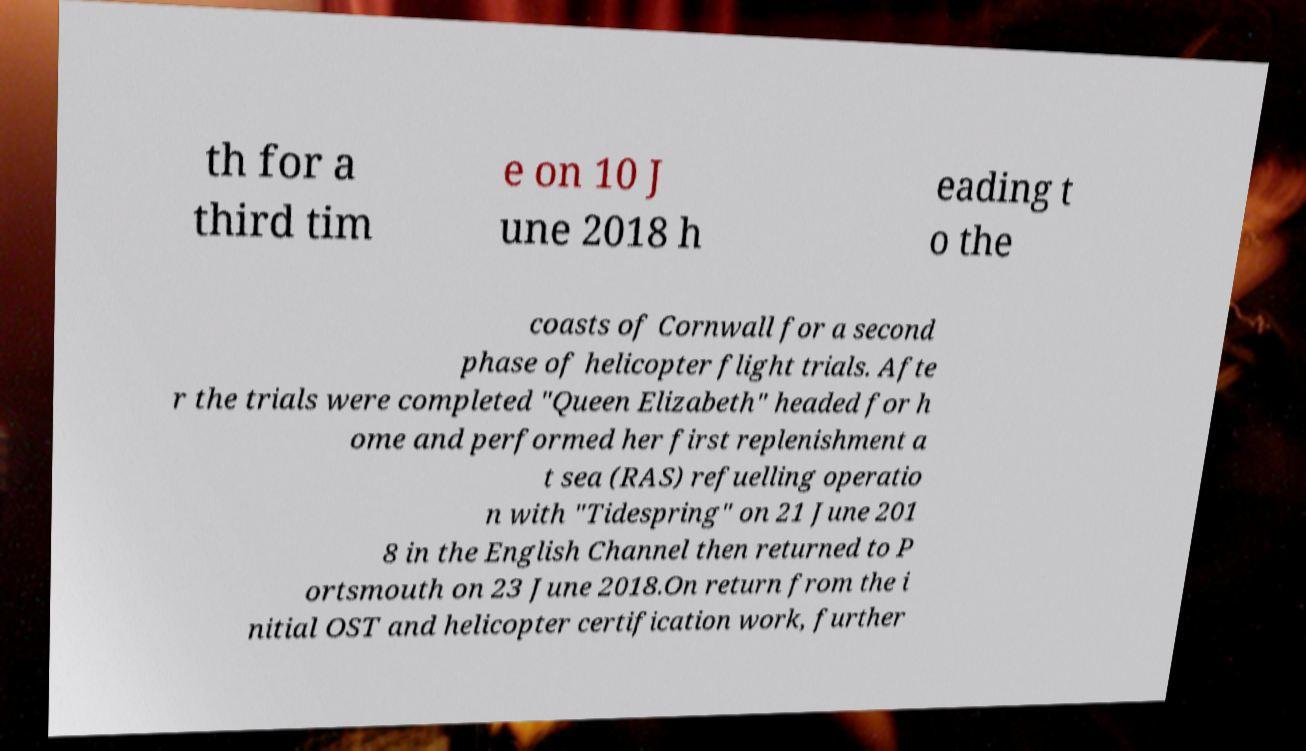Can you read and provide the text displayed in the image?This photo seems to have some interesting text. Can you extract and type it out for me? th for a third tim e on 10 J une 2018 h eading t o the coasts of Cornwall for a second phase of helicopter flight trials. Afte r the trials were completed "Queen Elizabeth" headed for h ome and performed her first replenishment a t sea (RAS) refuelling operatio n with "Tidespring" on 21 June 201 8 in the English Channel then returned to P ortsmouth on 23 June 2018.On return from the i nitial OST and helicopter certification work, further 